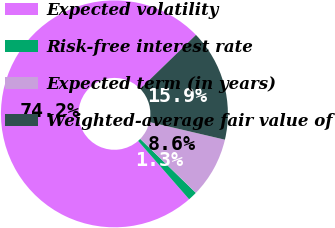Convert chart. <chart><loc_0><loc_0><loc_500><loc_500><pie_chart><fcel>Expected volatility<fcel>Risk-free interest rate<fcel>Expected term (in years)<fcel>Weighted-average fair value of<nl><fcel>74.19%<fcel>1.31%<fcel>8.6%<fcel>15.9%<nl></chart> 